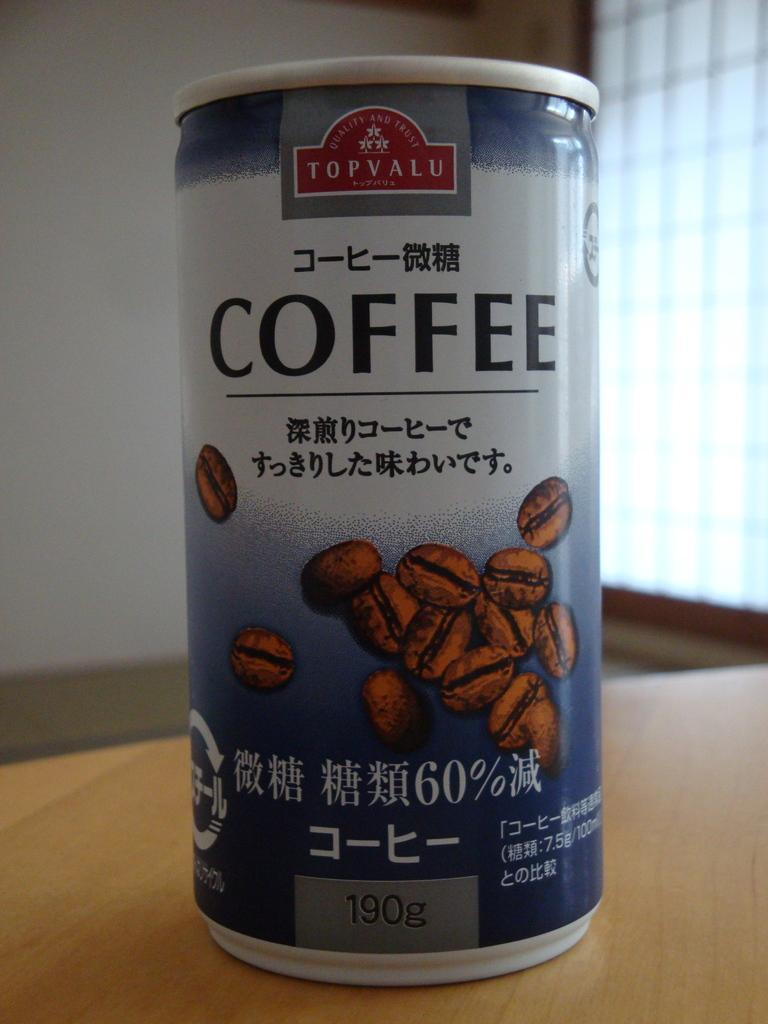<image>
Render a clear and concise summary of the photo. A can of Topvalu brand coffee with asian characters on it. 